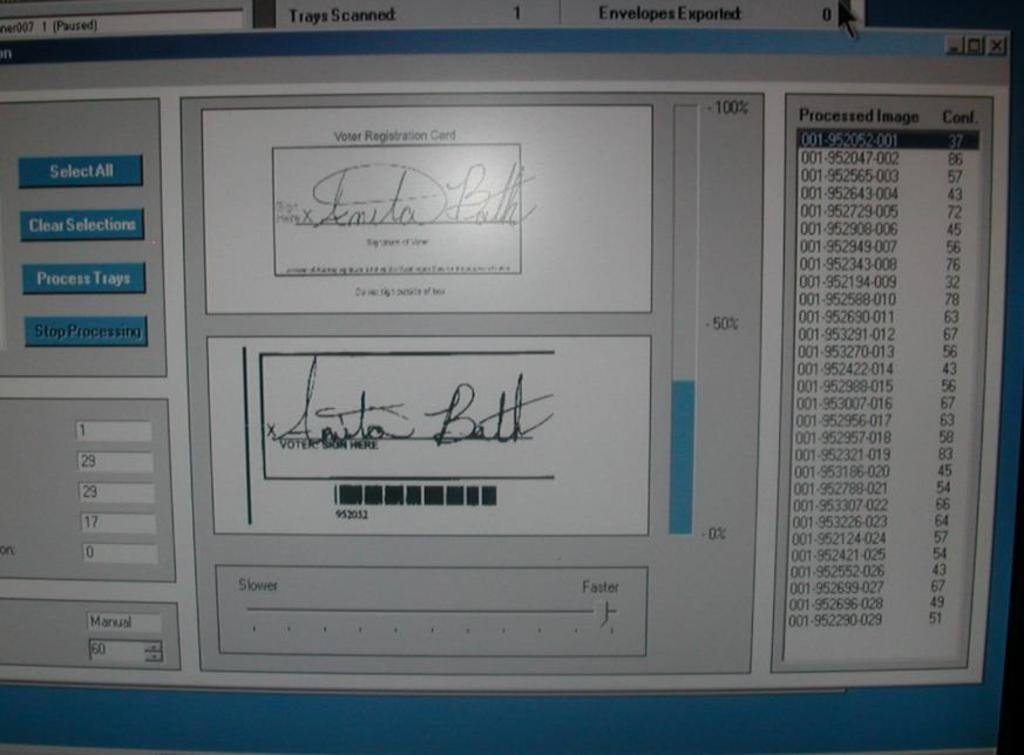<image>
Provide a brief description of the given image. A screen with two signatures on it both with say amita bath. 